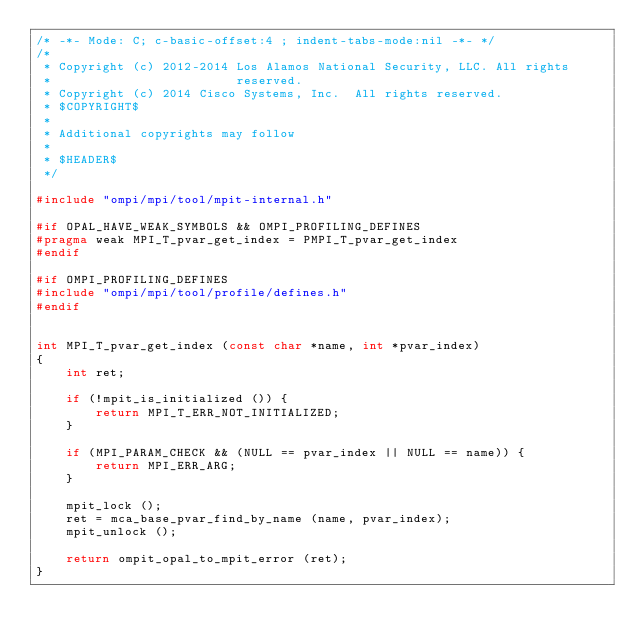<code> <loc_0><loc_0><loc_500><loc_500><_C_>/* -*- Mode: C; c-basic-offset:4 ; indent-tabs-mode:nil -*- */
/*
 * Copyright (c) 2012-2014 Los Alamos National Security, LLC. All rights
 *                         reserved.
 * Copyright (c) 2014 Cisco Systems, Inc.  All rights reserved.
 * $COPYRIGHT$
 *
 * Additional copyrights may follow
 *
 * $HEADER$
 */

#include "ompi/mpi/tool/mpit-internal.h"

#if OPAL_HAVE_WEAK_SYMBOLS && OMPI_PROFILING_DEFINES
#pragma weak MPI_T_pvar_get_index = PMPI_T_pvar_get_index
#endif

#if OMPI_PROFILING_DEFINES
#include "ompi/mpi/tool/profile/defines.h"
#endif


int MPI_T_pvar_get_index (const char *name, int *pvar_index)
{
    int ret;

    if (!mpit_is_initialized ()) {
        return MPI_T_ERR_NOT_INITIALIZED;
    }

    if (MPI_PARAM_CHECK && (NULL == pvar_index || NULL == name)) {
        return MPI_ERR_ARG;
    }

    mpit_lock ();
    ret = mca_base_pvar_find_by_name (name, pvar_index);
    mpit_unlock ();

    return ompit_opal_to_mpit_error (ret);
}
</code> 